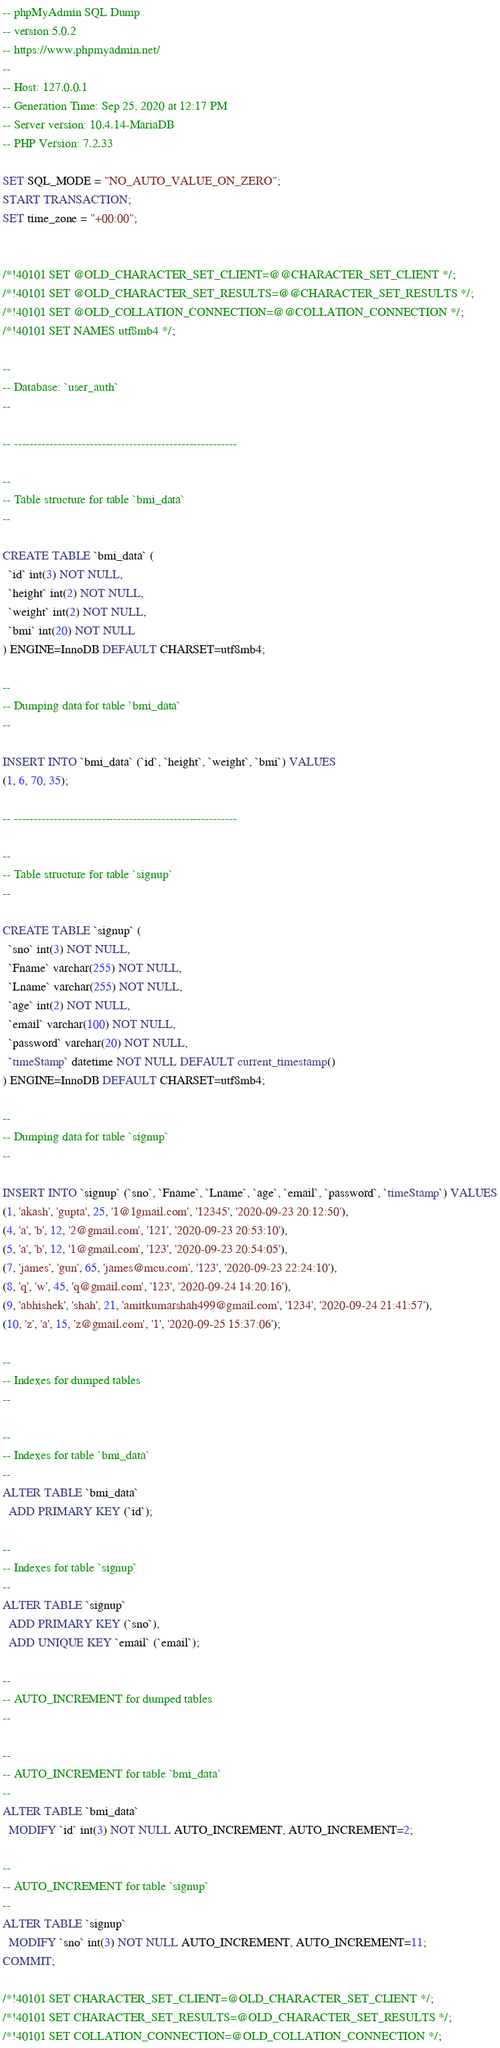Convert code to text. <code><loc_0><loc_0><loc_500><loc_500><_SQL_>-- phpMyAdmin SQL Dump
-- version 5.0.2
-- https://www.phpmyadmin.net/
--
-- Host: 127.0.0.1
-- Generation Time: Sep 25, 2020 at 12:17 PM
-- Server version: 10.4.14-MariaDB
-- PHP Version: 7.2.33

SET SQL_MODE = "NO_AUTO_VALUE_ON_ZERO";
START TRANSACTION;
SET time_zone = "+00:00";


/*!40101 SET @OLD_CHARACTER_SET_CLIENT=@@CHARACTER_SET_CLIENT */;
/*!40101 SET @OLD_CHARACTER_SET_RESULTS=@@CHARACTER_SET_RESULTS */;
/*!40101 SET @OLD_COLLATION_CONNECTION=@@COLLATION_CONNECTION */;
/*!40101 SET NAMES utf8mb4 */;

--
-- Database: `user_auth`
--

-- --------------------------------------------------------

--
-- Table structure for table `bmi_data`
--

CREATE TABLE `bmi_data` (
  `id` int(3) NOT NULL,
  `height` int(2) NOT NULL,
  `weight` int(2) NOT NULL,
  `bmi` int(20) NOT NULL
) ENGINE=InnoDB DEFAULT CHARSET=utf8mb4;

--
-- Dumping data for table `bmi_data`
--

INSERT INTO `bmi_data` (`id`, `height`, `weight`, `bmi`) VALUES
(1, 6, 70, 35);

-- --------------------------------------------------------

--
-- Table structure for table `signup`
--

CREATE TABLE `signup` (
  `sno` int(3) NOT NULL,
  `Fname` varchar(255) NOT NULL,
  `Lname` varchar(255) NOT NULL,
  `age` int(2) NOT NULL,
  `email` varchar(100) NOT NULL,
  `password` varchar(20) NOT NULL,
  `timeStamp` datetime NOT NULL DEFAULT current_timestamp()
) ENGINE=InnoDB DEFAULT CHARSET=utf8mb4;

--
-- Dumping data for table `signup`
--

INSERT INTO `signup` (`sno`, `Fname`, `Lname`, `age`, `email`, `password`, `timeStamp`) VALUES
(1, 'akash', 'gupta', 25, '1@1gmail.com', '12345', '2020-09-23 20:12:50'),
(4, 'a', 'b', 12, '2@gmail.com', '121', '2020-09-23 20:53:10'),
(5, 'a', 'b', 12, '1@gmail.com', '123', '2020-09-23 20:54:05'),
(7, 'james', 'gun', 65, 'james@mcu.com', '123', '2020-09-23 22:24:10'),
(8, 'q', 'w', 45, 'q@gmail.com', '123', '2020-09-24 14:20:16'),
(9, 'abhishek', 'shah', 21, 'amitkumarshah499@gmail.com', '1234', '2020-09-24 21:41:57'),
(10, 'z', 'a', 15, 'z@gmail.com', '1', '2020-09-25 15:37:06');

--
-- Indexes for dumped tables
--

--
-- Indexes for table `bmi_data`
--
ALTER TABLE `bmi_data`
  ADD PRIMARY KEY (`id`);

--
-- Indexes for table `signup`
--
ALTER TABLE `signup`
  ADD PRIMARY KEY (`sno`),
  ADD UNIQUE KEY `email` (`email`);

--
-- AUTO_INCREMENT for dumped tables
--

--
-- AUTO_INCREMENT for table `bmi_data`
--
ALTER TABLE `bmi_data`
  MODIFY `id` int(3) NOT NULL AUTO_INCREMENT, AUTO_INCREMENT=2;

--
-- AUTO_INCREMENT for table `signup`
--
ALTER TABLE `signup`
  MODIFY `sno` int(3) NOT NULL AUTO_INCREMENT, AUTO_INCREMENT=11;
COMMIT;

/*!40101 SET CHARACTER_SET_CLIENT=@OLD_CHARACTER_SET_CLIENT */;
/*!40101 SET CHARACTER_SET_RESULTS=@OLD_CHARACTER_SET_RESULTS */;
/*!40101 SET COLLATION_CONNECTION=@OLD_COLLATION_CONNECTION */;
</code> 